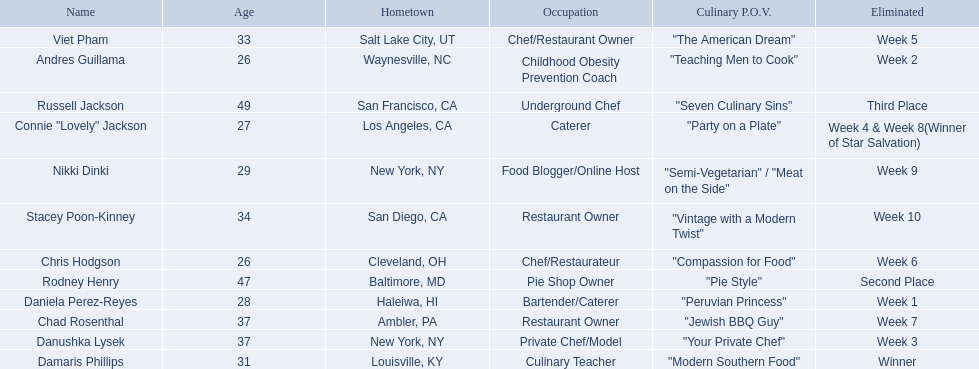Who where the people in the food network? Damaris Phillips, Rodney Henry, Russell Jackson, Stacey Poon-Kinney, Nikki Dinki, Chad Rosenthal, Chris Hodgson, Viet Pham, Connie "Lovely" Jackson, Danushka Lysek, Andres Guillama, Daniela Perez-Reyes. When was nikki dinki eliminated? Week 9. When was viet pham eliminated? Week 5. Which of these two is earlier? Week 5. Who was eliminated in this week? Viet Pham. Which food network star contestants are in their 20s? Nikki Dinki, Chris Hodgson, Connie "Lovely" Jackson, Andres Guillama, Daniela Perez-Reyes. Of these contestants, which one is the same age as chris hodgson? Andres Guillama. 